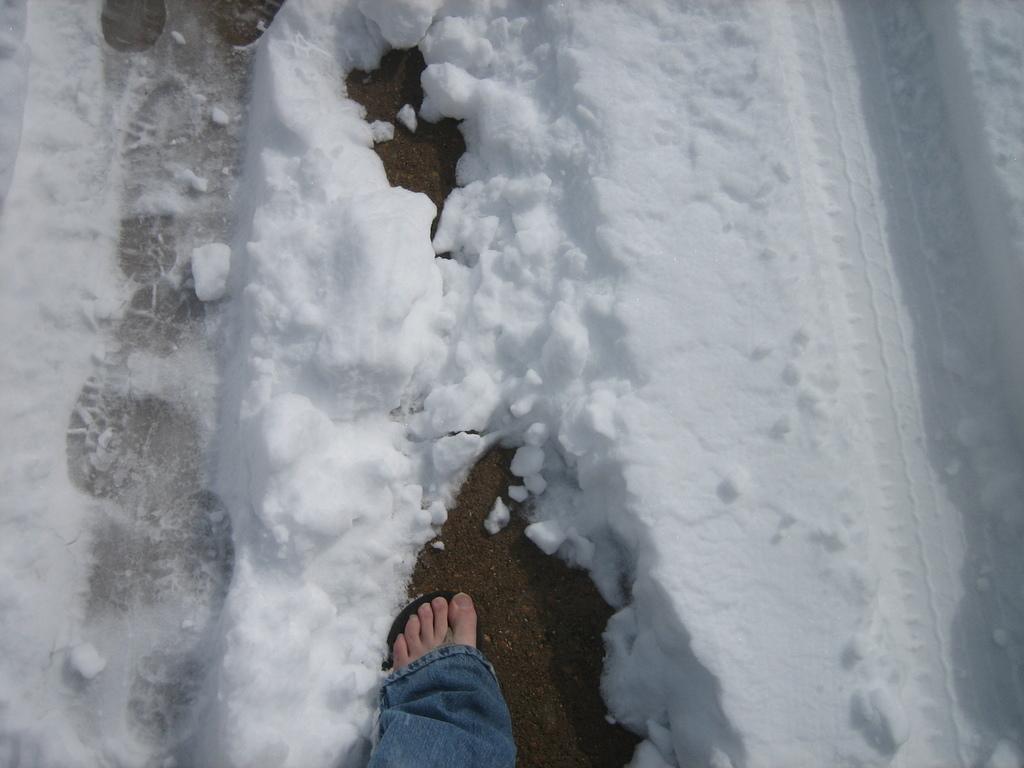Please provide a concise description of this image. In this image there is leg at the bottom. There are snow around the leg. 